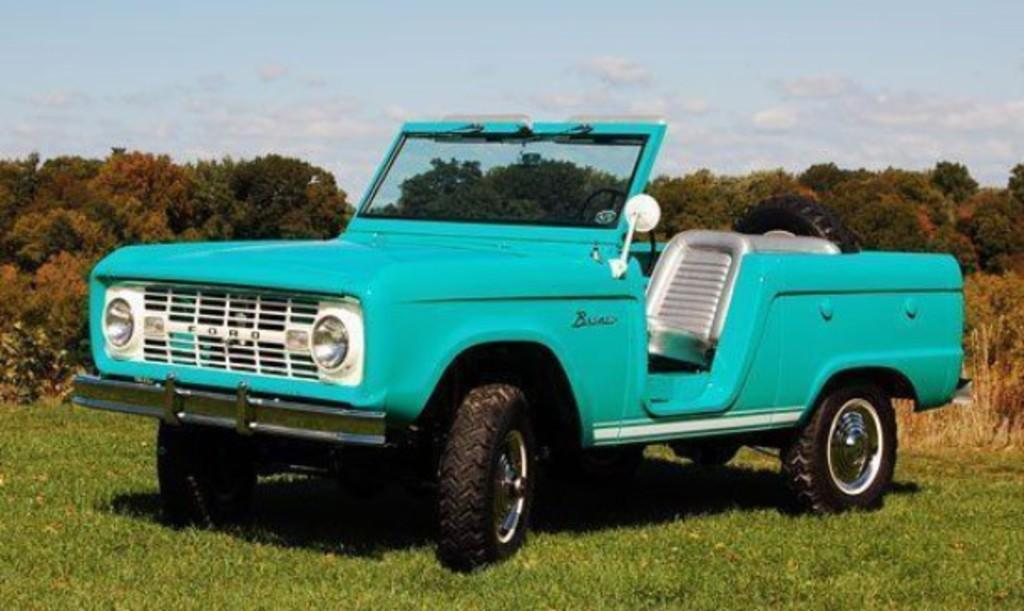What is the main subject of the image? The main subject of the image is a jeep. How is the jeep positioned in relation to other elements in the image? The jeep is in front of other elements in the image. What can be seen behind the jeep? There are trees behind the jeep. What is visible at the top of the image? The sky is visible at the top of the image. What can be observed in the sky? There are clouds in the sky. What suggestion does the jeep make to the trees in the image? The jeep does not make any suggestions in the image, as it is an inanimate object and cannot communicate. 